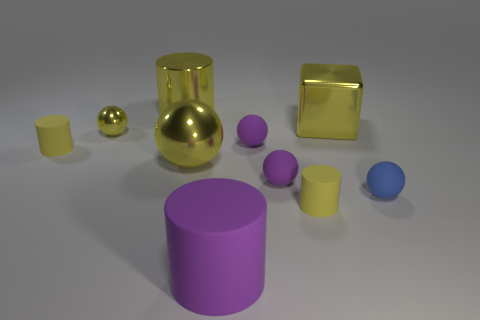How many other objects are the same color as the block?
Make the answer very short. 5. Are there any yellow rubber cylinders behind the cube?
Your answer should be compact. No. What number of other blue things are the same shape as the big matte thing?
Keep it short and to the point. 0. Is the blue object made of the same material as the big yellow ball in front of the yellow metallic cylinder?
Ensure brevity in your answer.  No. How many large metal things are there?
Your answer should be very brief. 3. What size is the metal thing to the right of the big matte object?
Provide a short and direct response. Large. What number of blue spheres are the same size as the blue matte thing?
Provide a succinct answer. 0. There is a yellow thing that is behind the small shiny thing and on the left side of the block; what is it made of?
Offer a terse response. Metal. There is a yellow sphere that is the same size as the blue ball; what material is it?
Make the answer very short. Metal. What size is the yellow ball on the right side of the metal thing behind the yellow metal thing to the right of the large rubber cylinder?
Provide a short and direct response. Large. 